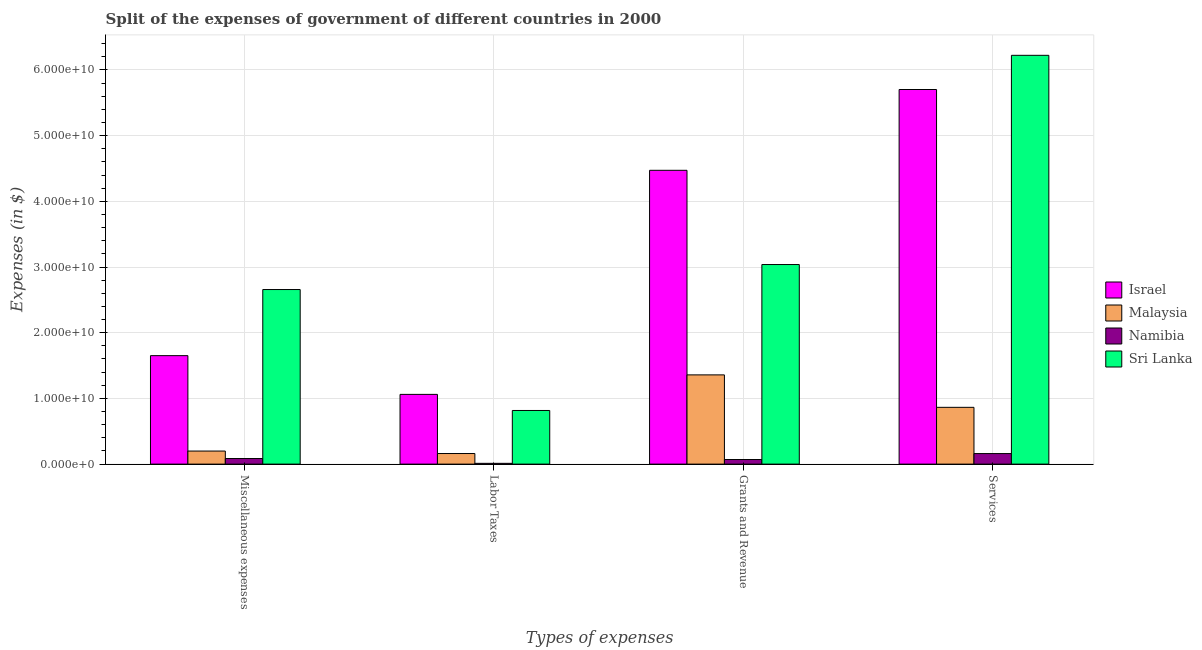How many different coloured bars are there?
Make the answer very short. 4. How many groups of bars are there?
Offer a very short reply. 4. Are the number of bars on each tick of the X-axis equal?
Make the answer very short. Yes. How many bars are there on the 4th tick from the left?
Ensure brevity in your answer.  4. What is the label of the 4th group of bars from the left?
Keep it short and to the point. Services. What is the amount spent on miscellaneous expenses in Israel?
Keep it short and to the point. 1.65e+1. Across all countries, what is the maximum amount spent on grants and revenue?
Give a very brief answer. 4.47e+1. Across all countries, what is the minimum amount spent on miscellaneous expenses?
Your response must be concise. 8.52e+08. In which country was the amount spent on services maximum?
Your answer should be compact. Sri Lanka. In which country was the amount spent on miscellaneous expenses minimum?
Offer a very short reply. Namibia. What is the total amount spent on miscellaneous expenses in the graph?
Your response must be concise. 4.59e+1. What is the difference between the amount spent on grants and revenue in Sri Lanka and that in Malaysia?
Your answer should be very brief. 1.68e+1. What is the difference between the amount spent on miscellaneous expenses in Malaysia and the amount spent on services in Namibia?
Keep it short and to the point. 3.84e+08. What is the average amount spent on labor taxes per country?
Your response must be concise. 5.13e+09. What is the difference between the amount spent on labor taxes and amount spent on grants and revenue in Sri Lanka?
Provide a succinct answer. -2.22e+1. What is the ratio of the amount spent on labor taxes in Namibia to that in Sri Lanka?
Provide a succinct answer. 0.01. What is the difference between the highest and the second highest amount spent on miscellaneous expenses?
Your answer should be compact. 1.01e+1. What is the difference between the highest and the lowest amount spent on services?
Make the answer very short. 6.06e+1. In how many countries, is the amount spent on miscellaneous expenses greater than the average amount spent on miscellaneous expenses taken over all countries?
Provide a short and direct response. 2. Is it the case that in every country, the sum of the amount spent on grants and revenue and amount spent on miscellaneous expenses is greater than the sum of amount spent on services and amount spent on labor taxes?
Your response must be concise. No. What does the 4th bar from the right in Services represents?
Provide a short and direct response. Israel. Are all the bars in the graph horizontal?
Provide a short and direct response. No. How many countries are there in the graph?
Offer a very short reply. 4. Does the graph contain any zero values?
Provide a succinct answer. No. Does the graph contain grids?
Make the answer very short. Yes. What is the title of the graph?
Your response must be concise. Split of the expenses of government of different countries in 2000. What is the label or title of the X-axis?
Provide a short and direct response. Types of expenses. What is the label or title of the Y-axis?
Your answer should be very brief. Expenses (in $). What is the Expenses (in $) in Israel in Miscellaneous expenses?
Provide a succinct answer. 1.65e+1. What is the Expenses (in $) of Malaysia in Miscellaneous expenses?
Your answer should be very brief. 1.99e+09. What is the Expenses (in $) in Namibia in Miscellaneous expenses?
Your answer should be very brief. 8.52e+08. What is the Expenses (in $) in Sri Lanka in Miscellaneous expenses?
Your response must be concise. 2.66e+1. What is the Expenses (in $) of Israel in Labor Taxes?
Provide a succinct answer. 1.06e+1. What is the Expenses (in $) of Malaysia in Labor Taxes?
Keep it short and to the point. 1.61e+09. What is the Expenses (in $) in Namibia in Labor Taxes?
Provide a short and direct response. 1.18e+08. What is the Expenses (in $) in Sri Lanka in Labor Taxes?
Ensure brevity in your answer.  8.16e+09. What is the Expenses (in $) in Israel in Grants and Revenue?
Give a very brief answer. 4.47e+1. What is the Expenses (in $) in Malaysia in Grants and Revenue?
Offer a terse response. 1.36e+1. What is the Expenses (in $) of Namibia in Grants and Revenue?
Offer a terse response. 6.99e+08. What is the Expenses (in $) in Sri Lanka in Grants and Revenue?
Offer a very short reply. 3.04e+1. What is the Expenses (in $) of Israel in Services?
Offer a very short reply. 5.70e+1. What is the Expenses (in $) in Malaysia in Services?
Provide a short and direct response. 8.64e+09. What is the Expenses (in $) of Namibia in Services?
Ensure brevity in your answer.  1.60e+09. What is the Expenses (in $) in Sri Lanka in Services?
Offer a very short reply. 6.22e+1. Across all Types of expenses, what is the maximum Expenses (in $) in Israel?
Your answer should be very brief. 5.70e+1. Across all Types of expenses, what is the maximum Expenses (in $) of Malaysia?
Provide a short and direct response. 1.36e+1. Across all Types of expenses, what is the maximum Expenses (in $) in Namibia?
Your response must be concise. 1.60e+09. Across all Types of expenses, what is the maximum Expenses (in $) in Sri Lanka?
Your answer should be very brief. 6.22e+1. Across all Types of expenses, what is the minimum Expenses (in $) in Israel?
Give a very brief answer. 1.06e+1. Across all Types of expenses, what is the minimum Expenses (in $) of Malaysia?
Provide a short and direct response. 1.61e+09. Across all Types of expenses, what is the minimum Expenses (in $) of Namibia?
Provide a short and direct response. 1.18e+08. Across all Types of expenses, what is the minimum Expenses (in $) in Sri Lanka?
Offer a very short reply. 8.16e+09. What is the total Expenses (in $) of Israel in the graph?
Your answer should be very brief. 1.29e+11. What is the total Expenses (in $) of Malaysia in the graph?
Give a very brief answer. 2.58e+1. What is the total Expenses (in $) in Namibia in the graph?
Give a very brief answer. 3.27e+09. What is the total Expenses (in $) of Sri Lanka in the graph?
Your answer should be very brief. 1.27e+11. What is the difference between the Expenses (in $) of Israel in Miscellaneous expenses and that in Labor Taxes?
Your response must be concise. 5.90e+09. What is the difference between the Expenses (in $) of Malaysia in Miscellaneous expenses and that in Labor Taxes?
Your answer should be very brief. 3.75e+08. What is the difference between the Expenses (in $) of Namibia in Miscellaneous expenses and that in Labor Taxes?
Your response must be concise. 7.34e+08. What is the difference between the Expenses (in $) in Sri Lanka in Miscellaneous expenses and that in Labor Taxes?
Your response must be concise. 1.84e+1. What is the difference between the Expenses (in $) in Israel in Miscellaneous expenses and that in Grants and Revenue?
Your response must be concise. -2.82e+1. What is the difference between the Expenses (in $) in Malaysia in Miscellaneous expenses and that in Grants and Revenue?
Your answer should be compact. -1.16e+1. What is the difference between the Expenses (in $) in Namibia in Miscellaneous expenses and that in Grants and Revenue?
Make the answer very short. 1.53e+08. What is the difference between the Expenses (in $) in Sri Lanka in Miscellaneous expenses and that in Grants and Revenue?
Make the answer very short. -3.81e+09. What is the difference between the Expenses (in $) in Israel in Miscellaneous expenses and that in Services?
Provide a succinct answer. -4.05e+1. What is the difference between the Expenses (in $) of Malaysia in Miscellaneous expenses and that in Services?
Your answer should be compact. -6.65e+09. What is the difference between the Expenses (in $) of Namibia in Miscellaneous expenses and that in Services?
Provide a succinct answer. -7.52e+08. What is the difference between the Expenses (in $) of Sri Lanka in Miscellaneous expenses and that in Services?
Your answer should be compact. -3.57e+1. What is the difference between the Expenses (in $) of Israel in Labor Taxes and that in Grants and Revenue?
Give a very brief answer. -3.41e+1. What is the difference between the Expenses (in $) of Malaysia in Labor Taxes and that in Grants and Revenue?
Keep it short and to the point. -1.20e+1. What is the difference between the Expenses (in $) of Namibia in Labor Taxes and that in Grants and Revenue?
Offer a very short reply. -5.81e+08. What is the difference between the Expenses (in $) of Sri Lanka in Labor Taxes and that in Grants and Revenue?
Give a very brief answer. -2.22e+1. What is the difference between the Expenses (in $) of Israel in Labor Taxes and that in Services?
Make the answer very short. -4.64e+1. What is the difference between the Expenses (in $) in Malaysia in Labor Taxes and that in Services?
Keep it short and to the point. -7.03e+09. What is the difference between the Expenses (in $) of Namibia in Labor Taxes and that in Services?
Your response must be concise. -1.49e+09. What is the difference between the Expenses (in $) of Sri Lanka in Labor Taxes and that in Services?
Offer a terse response. -5.41e+1. What is the difference between the Expenses (in $) in Israel in Grants and Revenue and that in Services?
Your response must be concise. -1.23e+1. What is the difference between the Expenses (in $) in Malaysia in Grants and Revenue and that in Services?
Provide a succinct answer. 4.94e+09. What is the difference between the Expenses (in $) in Namibia in Grants and Revenue and that in Services?
Offer a terse response. -9.05e+08. What is the difference between the Expenses (in $) of Sri Lanka in Grants and Revenue and that in Services?
Offer a very short reply. -3.18e+1. What is the difference between the Expenses (in $) in Israel in Miscellaneous expenses and the Expenses (in $) in Malaysia in Labor Taxes?
Make the answer very short. 1.49e+1. What is the difference between the Expenses (in $) in Israel in Miscellaneous expenses and the Expenses (in $) in Namibia in Labor Taxes?
Make the answer very short. 1.64e+1. What is the difference between the Expenses (in $) of Israel in Miscellaneous expenses and the Expenses (in $) of Sri Lanka in Labor Taxes?
Keep it short and to the point. 8.35e+09. What is the difference between the Expenses (in $) of Malaysia in Miscellaneous expenses and the Expenses (in $) of Namibia in Labor Taxes?
Provide a succinct answer. 1.87e+09. What is the difference between the Expenses (in $) in Malaysia in Miscellaneous expenses and the Expenses (in $) in Sri Lanka in Labor Taxes?
Keep it short and to the point. -6.18e+09. What is the difference between the Expenses (in $) in Namibia in Miscellaneous expenses and the Expenses (in $) in Sri Lanka in Labor Taxes?
Your answer should be very brief. -7.31e+09. What is the difference between the Expenses (in $) of Israel in Miscellaneous expenses and the Expenses (in $) of Malaysia in Grants and Revenue?
Your response must be concise. 2.93e+09. What is the difference between the Expenses (in $) of Israel in Miscellaneous expenses and the Expenses (in $) of Namibia in Grants and Revenue?
Your answer should be very brief. 1.58e+1. What is the difference between the Expenses (in $) in Israel in Miscellaneous expenses and the Expenses (in $) in Sri Lanka in Grants and Revenue?
Your answer should be very brief. -1.39e+1. What is the difference between the Expenses (in $) in Malaysia in Miscellaneous expenses and the Expenses (in $) in Namibia in Grants and Revenue?
Provide a succinct answer. 1.29e+09. What is the difference between the Expenses (in $) in Malaysia in Miscellaneous expenses and the Expenses (in $) in Sri Lanka in Grants and Revenue?
Ensure brevity in your answer.  -2.84e+1. What is the difference between the Expenses (in $) in Namibia in Miscellaneous expenses and the Expenses (in $) in Sri Lanka in Grants and Revenue?
Keep it short and to the point. -2.95e+1. What is the difference between the Expenses (in $) of Israel in Miscellaneous expenses and the Expenses (in $) of Malaysia in Services?
Offer a terse response. 7.87e+09. What is the difference between the Expenses (in $) of Israel in Miscellaneous expenses and the Expenses (in $) of Namibia in Services?
Ensure brevity in your answer.  1.49e+1. What is the difference between the Expenses (in $) of Israel in Miscellaneous expenses and the Expenses (in $) of Sri Lanka in Services?
Make the answer very short. -4.57e+1. What is the difference between the Expenses (in $) in Malaysia in Miscellaneous expenses and the Expenses (in $) in Namibia in Services?
Ensure brevity in your answer.  3.84e+08. What is the difference between the Expenses (in $) in Malaysia in Miscellaneous expenses and the Expenses (in $) in Sri Lanka in Services?
Your response must be concise. -6.02e+1. What is the difference between the Expenses (in $) in Namibia in Miscellaneous expenses and the Expenses (in $) in Sri Lanka in Services?
Ensure brevity in your answer.  -6.14e+1. What is the difference between the Expenses (in $) in Israel in Labor Taxes and the Expenses (in $) in Malaysia in Grants and Revenue?
Your answer should be very brief. -2.97e+09. What is the difference between the Expenses (in $) in Israel in Labor Taxes and the Expenses (in $) in Namibia in Grants and Revenue?
Offer a terse response. 9.91e+09. What is the difference between the Expenses (in $) in Israel in Labor Taxes and the Expenses (in $) in Sri Lanka in Grants and Revenue?
Ensure brevity in your answer.  -1.98e+1. What is the difference between the Expenses (in $) of Malaysia in Labor Taxes and the Expenses (in $) of Namibia in Grants and Revenue?
Your response must be concise. 9.14e+08. What is the difference between the Expenses (in $) of Malaysia in Labor Taxes and the Expenses (in $) of Sri Lanka in Grants and Revenue?
Offer a very short reply. -2.88e+1. What is the difference between the Expenses (in $) in Namibia in Labor Taxes and the Expenses (in $) in Sri Lanka in Grants and Revenue?
Keep it short and to the point. -3.03e+1. What is the difference between the Expenses (in $) of Israel in Labor Taxes and the Expenses (in $) of Malaysia in Services?
Offer a very short reply. 1.97e+09. What is the difference between the Expenses (in $) in Israel in Labor Taxes and the Expenses (in $) in Namibia in Services?
Keep it short and to the point. 9.01e+09. What is the difference between the Expenses (in $) of Israel in Labor Taxes and the Expenses (in $) of Sri Lanka in Services?
Offer a terse response. -5.16e+1. What is the difference between the Expenses (in $) in Malaysia in Labor Taxes and the Expenses (in $) in Namibia in Services?
Make the answer very short. 9.12e+06. What is the difference between the Expenses (in $) in Malaysia in Labor Taxes and the Expenses (in $) in Sri Lanka in Services?
Give a very brief answer. -6.06e+1. What is the difference between the Expenses (in $) in Namibia in Labor Taxes and the Expenses (in $) in Sri Lanka in Services?
Provide a short and direct response. -6.21e+1. What is the difference between the Expenses (in $) in Israel in Grants and Revenue and the Expenses (in $) in Malaysia in Services?
Give a very brief answer. 3.61e+1. What is the difference between the Expenses (in $) in Israel in Grants and Revenue and the Expenses (in $) in Namibia in Services?
Your answer should be very brief. 4.31e+1. What is the difference between the Expenses (in $) in Israel in Grants and Revenue and the Expenses (in $) in Sri Lanka in Services?
Make the answer very short. -1.75e+1. What is the difference between the Expenses (in $) in Malaysia in Grants and Revenue and the Expenses (in $) in Namibia in Services?
Offer a terse response. 1.20e+1. What is the difference between the Expenses (in $) in Malaysia in Grants and Revenue and the Expenses (in $) in Sri Lanka in Services?
Provide a short and direct response. -4.86e+1. What is the difference between the Expenses (in $) in Namibia in Grants and Revenue and the Expenses (in $) in Sri Lanka in Services?
Give a very brief answer. -6.15e+1. What is the average Expenses (in $) of Israel per Types of expenses?
Offer a very short reply. 3.22e+1. What is the average Expenses (in $) of Malaysia per Types of expenses?
Provide a succinct answer. 6.46e+09. What is the average Expenses (in $) in Namibia per Types of expenses?
Keep it short and to the point. 8.18e+08. What is the average Expenses (in $) in Sri Lanka per Types of expenses?
Keep it short and to the point. 3.18e+1. What is the difference between the Expenses (in $) of Israel and Expenses (in $) of Malaysia in Miscellaneous expenses?
Offer a very short reply. 1.45e+1. What is the difference between the Expenses (in $) in Israel and Expenses (in $) in Namibia in Miscellaneous expenses?
Ensure brevity in your answer.  1.57e+1. What is the difference between the Expenses (in $) of Israel and Expenses (in $) of Sri Lanka in Miscellaneous expenses?
Your answer should be very brief. -1.01e+1. What is the difference between the Expenses (in $) in Malaysia and Expenses (in $) in Namibia in Miscellaneous expenses?
Your answer should be compact. 1.14e+09. What is the difference between the Expenses (in $) in Malaysia and Expenses (in $) in Sri Lanka in Miscellaneous expenses?
Provide a succinct answer. -2.46e+1. What is the difference between the Expenses (in $) in Namibia and Expenses (in $) in Sri Lanka in Miscellaneous expenses?
Your answer should be very brief. -2.57e+1. What is the difference between the Expenses (in $) in Israel and Expenses (in $) in Malaysia in Labor Taxes?
Your answer should be very brief. 9.00e+09. What is the difference between the Expenses (in $) in Israel and Expenses (in $) in Namibia in Labor Taxes?
Provide a short and direct response. 1.05e+1. What is the difference between the Expenses (in $) in Israel and Expenses (in $) in Sri Lanka in Labor Taxes?
Provide a short and direct response. 2.45e+09. What is the difference between the Expenses (in $) of Malaysia and Expenses (in $) of Namibia in Labor Taxes?
Provide a short and direct response. 1.50e+09. What is the difference between the Expenses (in $) of Malaysia and Expenses (in $) of Sri Lanka in Labor Taxes?
Provide a short and direct response. -6.55e+09. What is the difference between the Expenses (in $) of Namibia and Expenses (in $) of Sri Lanka in Labor Taxes?
Give a very brief answer. -8.05e+09. What is the difference between the Expenses (in $) of Israel and Expenses (in $) of Malaysia in Grants and Revenue?
Give a very brief answer. 3.11e+1. What is the difference between the Expenses (in $) of Israel and Expenses (in $) of Namibia in Grants and Revenue?
Keep it short and to the point. 4.40e+1. What is the difference between the Expenses (in $) in Israel and Expenses (in $) in Sri Lanka in Grants and Revenue?
Your response must be concise. 1.43e+1. What is the difference between the Expenses (in $) in Malaysia and Expenses (in $) in Namibia in Grants and Revenue?
Provide a short and direct response. 1.29e+1. What is the difference between the Expenses (in $) in Malaysia and Expenses (in $) in Sri Lanka in Grants and Revenue?
Offer a terse response. -1.68e+1. What is the difference between the Expenses (in $) in Namibia and Expenses (in $) in Sri Lanka in Grants and Revenue?
Provide a short and direct response. -2.97e+1. What is the difference between the Expenses (in $) of Israel and Expenses (in $) of Malaysia in Services?
Ensure brevity in your answer.  4.84e+1. What is the difference between the Expenses (in $) of Israel and Expenses (in $) of Namibia in Services?
Ensure brevity in your answer.  5.54e+1. What is the difference between the Expenses (in $) in Israel and Expenses (in $) in Sri Lanka in Services?
Provide a short and direct response. -5.20e+09. What is the difference between the Expenses (in $) in Malaysia and Expenses (in $) in Namibia in Services?
Provide a short and direct response. 7.04e+09. What is the difference between the Expenses (in $) in Malaysia and Expenses (in $) in Sri Lanka in Services?
Offer a terse response. -5.36e+1. What is the difference between the Expenses (in $) in Namibia and Expenses (in $) in Sri Lanka in Services?
Offer a very short reply. -6.06e+1. What is the ratio of the Expenses (in $) in Israel in Miscellaneous expenses to that in Labor Taxes?
Give a very brief answer. 1.56. What is the ratio of the Expenses (in $) of Malaysia in Miscellaneous expenses to that in Labor Taxes?
Your answer should be very brief. 1.23. What is the ratio of the Expenses (in $) in Namibia in Miscellaneous expenses to that in Labor Taxes?
Provide a short and direct response. 7.23. What is the ratio of the Expenses (in $) in Sri Lanka in Miscellaneous expenses to that in Labor Taxes?
Provide a short and direct response. 3.25. What is the ratio of the Expenses (in $) of Israel in Miscellaneous expenses to that in Grants and Revenue?
Your response must be concise. 0.37. What is the ratio of the Expenses (in $) in Malaysia in Miscellaneous expenses to that in Grants and Revenue?
Offer a very short reply. 0.15. What is the ratio of the Expenses (in $) of Namibia in Miscellaneous expenses to that in Grants and Revenue?
Keep it short and to the point. 1.22. What is the ratio of the Expenses (in $) in Sri Lanka in Miscellaneous expenses to that in Grants and Revenue?
Your answer should be compact. 0.87. What is the ratio of the Expenses (in $) in Israel in Miscellaneous expenses to that in Services?
Your answer should be very brief. 0.29. What is the ratio of the Expenses (in $) of Malaysia in Miscellaneous expenses to that in Services?
Your answer should be very brief. 0.23. What is the ratio of the Expenses (in $) in Namibia in Miscellaneous expenses to that in Services?
Make the answer very short. 0.53. What is the ratio of the Expenses (in $) in Sri Lanka in Miscellaneous expenses to that in Services?
Keep it short and to the point. 0.43. What is the ratio of the Expenses (in $) of Israel in Labor Taxes to that in Grants and Revenue?
Your answer should be very brief. 0.24. What is the ratio of the Expenses (in $) in Malaysia in Labor Taxes to that in Grants and Revenue?
Give a very brief answer. 0.12. What is the ratio of the Expenses (in $) in Namibia in Labor Taxes to that in Grants and Revenue?
Keep it short and to the point. 0.17. What is the ratio of the Expenses (in $) in Sri Lanka in Labor Taxes to that in Grants and Revenue?
Keep it short and to the point. 0.27. What is the ratio of the Expenses (in $) in Israel in Labor Taxes to that in Services?
Make the answer very short. 0.19. What is the ratio of the Expenses (in $) of Malaysia in Labor Taxes to that in Services?
Ensure brevity in your answer.  0.19. What is the ratio of the Expenses (in $) in Namibia in Labor Taxes to that in Services?
Give a very brief answer. 0.07. What is the ratio of the Expenses (in $) in Sri Lanka in Labor Taxes to that in Services?
Your response must be concise. 0.13. What is the ratio of the Expenses (in $) in Israel in Grants and Revenue to that in Services?
Make the answer very short. 0.78. What is the ratio of the Expenses (in $) of Malaysia in Grants and Revenue to that in Services?
Your answer should be compact. 1.57. What is the ratio of the Expenses (in $) of Namibia in Grants and Revenue to that in Services?
Your answer should be very brief. 0.44. What is the ratio of the Expenses (in $) in Sri Lanka in Grants and Revenue to that in Services?
Make the answer very short. 0.49. What is the difference between the highest and the second highest Expenses (in $) of Israel?
Make the answer very short. 1.23e+1. What is the difference between the highest and the second highest Expenses (in $) in Malaysia?
Make the answer very short. 4.94e+09. What is the difference between the highest and the second highest Expenses (in $) in Namibia?
Ensure brevity in your answer.  7.52e+08. What is the difference between the highest and the second highest Expenses (in $) in Sri Lanka?
Your answer should be very brief. 3.18e+1. What is the difference between the highest and the lowest Expenses (in $) of Israel?
Keep it short and to the point. 4.64e+1. What is the difference between the highest and the lowest Expenses (in $) in Malaysia?
Keep it short and to the point. 1.20e+1. What is the difference between the highest and the lowest Expenses (in $) in Namibia?
Offer a terse response. 1.49e+09. What is the difference between the highest and the lowest Expenses (in $) in Sri Lanka?
Your response must be concise. 5.41e+1. 